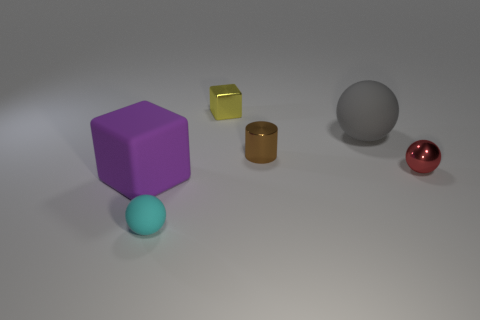There is a ball behind the red metal sphere; is it the same size as the yellow block?
Offer a very short reply. No. What size is the purple object that is the same shape as the yellow thing?
Keep it short and to the point. Large. There is a gray object that is the same size as the purple rubber object; what material is it?
Offer a very short reply. Rubber. What material is the big purple thing that is the same shape as the small yellow shiny object?
Keep it short and to the point. Rubber. What number of other things are there of the same size as the cyan rubber thing?
Give a very brief answer. 3. What number of large objects have the same color as the large block?
Your response must be concise. 0. There is a brown object; what shape is it?
Offer a very short reply. Cylinder. The rubber object that is both behind the cyan thing and left of the big gray object is what color?
Provide a short and direct response. Purple. What is the tiny cylinder made of?
Provide a short and direct response. Metal. What is the shape of the metallic thing on the right side of the gray rubber ball?
Offer a terse response. Sphere. 